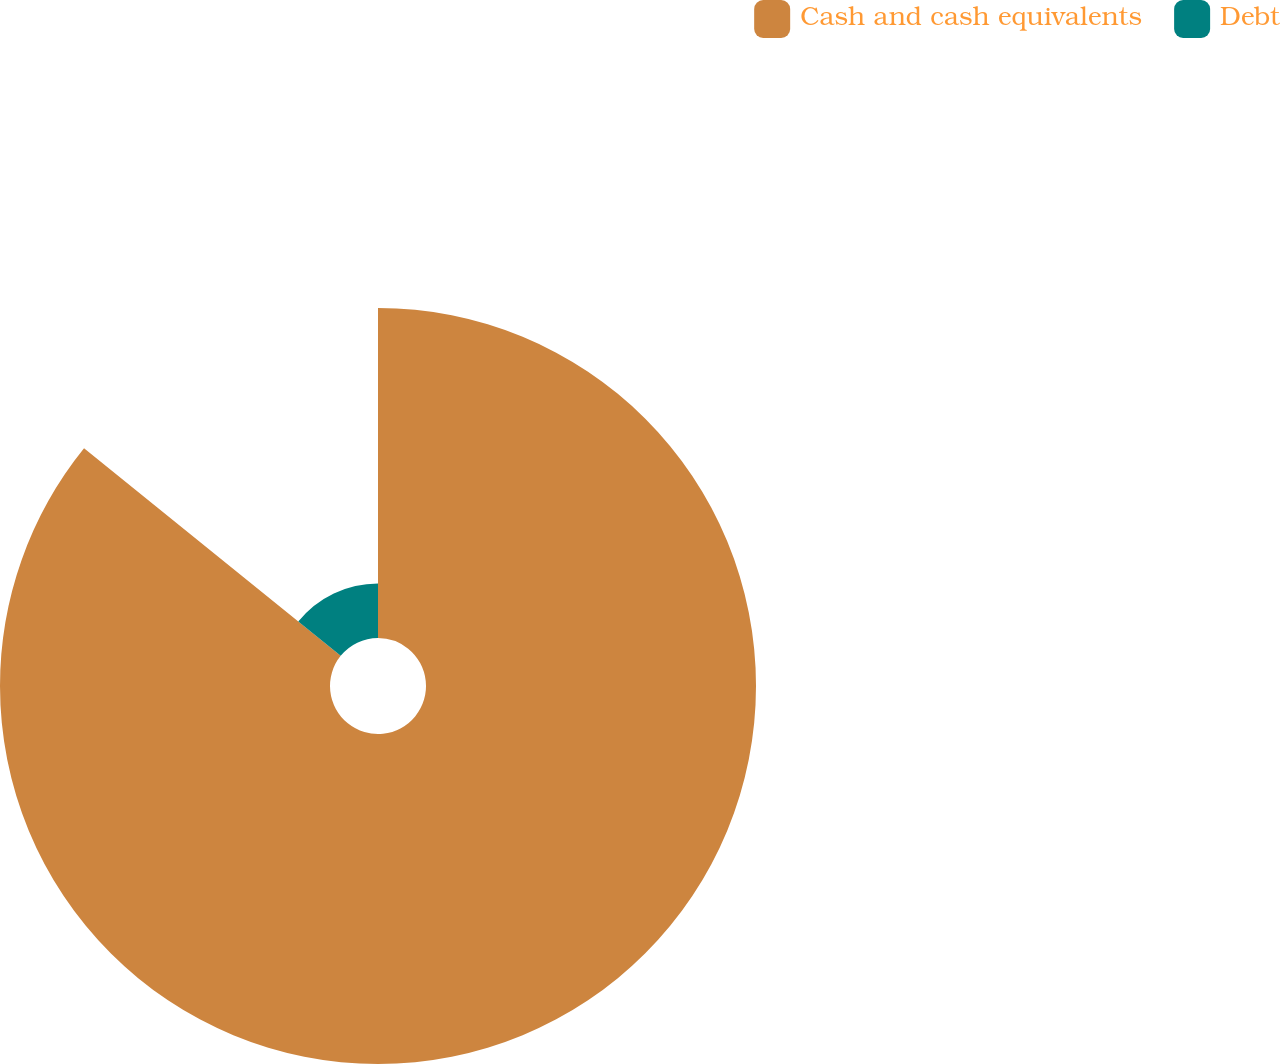Convert chart. <chart><loc_0><loc_0><loc_500><loc_500><pie_chart><fcel>Cash and cash equivalents<fcel>Debt<nl><fcel>85.82%<fcel>14.18%<nl></chart> 